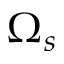Convert formula to latex. <formula><loc_0><loc_0><loc_500><loc_500>\Omega _ { s }</formula> 